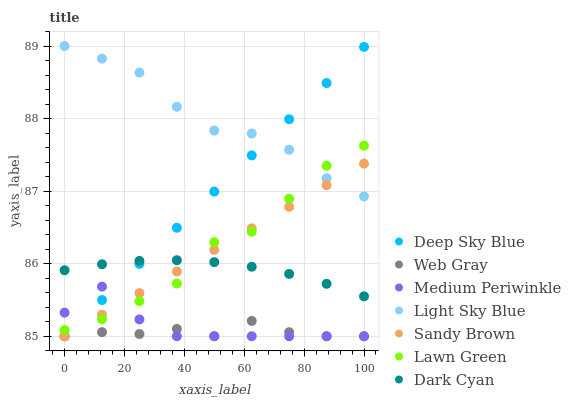Does Web Gray have the minimum area under the curve?
Answer yes or no. Yes. Does Light Sky Blue have the maximum area under the curve?
Answer yes or no. Yes. Does Medium Periwinkle have the minimum area under the curve?
Answer yes or no. No. Does Medium Periwinkle have the maximum area under the curve?
Answer yes or no. No. Is Sandy Brown the smoothest?
Answer yes or no. Yes. Is Lawn Green the roughest?
Answer yes or no. Yes. Is Web Gray the smoothest?
Answer yes or no. No. Is Web Gray the roughest?
Answer yes or no. No. Does Web Gray have the lowest value?
Answer yes or no. Yes. Does Light Sky Blue have the lowest value?
Answer yes or no. No. Does Light Sky Blue have the highest value?
Answer yes or no. Yes. Does Medium Periwinkle have the highest value?
Answer yes or no. No. Is Medium Periwinkle less than Dark Cyan?
Answer yes or no. Yes. Is Light Sky Blue greater than Web Gray?
Answer yes or no. Yes. Does Light Sky Blue intersect Deep Sky Blue?
Answer yes or no. Yes. Is Light Sky Blue less than Deep Sky Blue?
Answer yes or no. No. Is Light Sky Blue greater than Deep Sky Blue?
Answer yes or no. No. Does Medium Periwinkle intersect Dark Cyan?
Answer yes or no. No. 